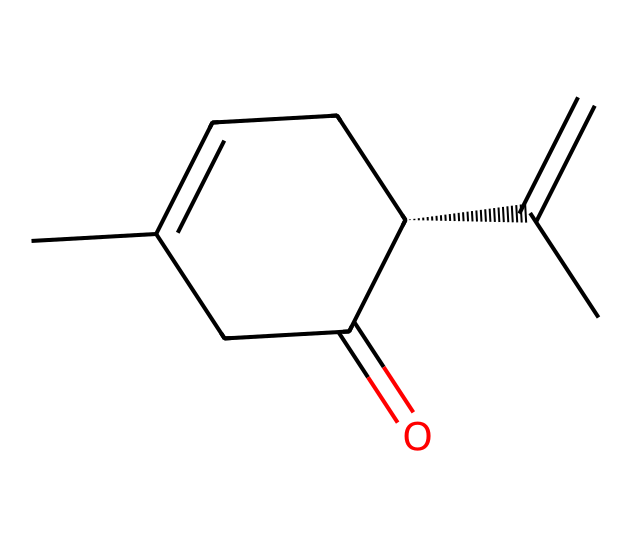What is the molecular formula of carvone? To determine the molecular formula, count the carbon (C), hydrogen (H), and oxygen (O) atoms present in the structure. The structure shows 10 carbons, 14 hydrogens, and 1 oxygen. Therefore, the molecular formula is C10H14O.
Answer: C10H14O How many chiral centers are present in carvone? A chiral center is usually a carbon atom that is attached to four different groups. In the structure, there is one carbon atom with four different substituents attached to it, which makes it a chiral compound.
Answer: 1 What unique feature does carvone have that makes it chiral? The unique feature making carvone chiral is the presence of a carbon atom bonded to four distinct groups, resulting in non-superimposable mirror images.
Answer: Non-superimposable mirror images What are the distinct aromas associated with carvone? Carvone is known for its two distinct aromas: one resembling spearmint and the other resembling caraway. These aromas are due to its specific stereochemistry.
Answer: Spearmint and caraway What type of compound is carvone classified as? Carvone is classified as a monoterpene, which is a type of terpenoid compound derived from plants and often associated with essential oils.
Answer: Monoterpene Which functional group is present in the carvone structure? The presence of a carbonyl group (C=O) indicates that carvone contains a ketone functional group, which is characteristic of its structure.
Answer: Ketone 